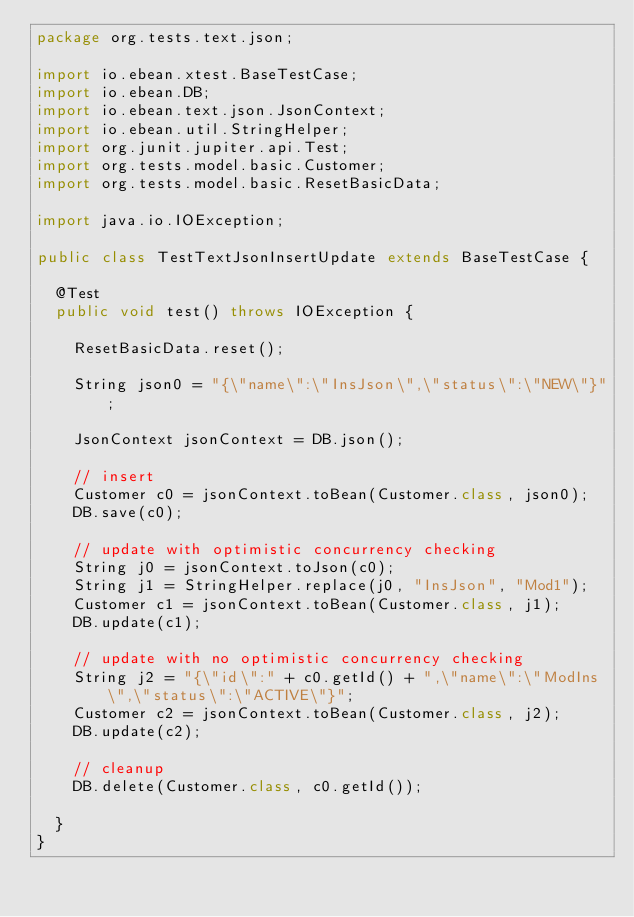<code> <loc_0><loc_0><loc_500><loc_500><_Java_>package org.tests.text.json;

import io.ebean.xtest.BaseTestCase;
import io.ebean.DB;
import io.ebean.text.json.JsonContext;
import io.ebean.util.StringHelper;
import org.junit.jupiter.api.Test;
import org.tests.model.basic.Customer;
import org.tests.model.basic.ResetBasicData;

import java.io.IOException;

public class TestTextJsonInsertUpdate extends BaseTestCase {

  @Test
  public void test() throws IOException {

    ResetBasicData.reset();

    String json0 = "{\"name\":\"InsJson\",\"status\":\"NEW\"}";

    JsonContext jsonContext = DB.json();

    // insert
    Customer c0 = jsonContext.toBean(Customer.class, json0);
    DB.save(c0);

    // update with optimistic concurrency checking
    String j0 = jsonContext.toJson(c0);
    String j1 = StringHelper.replace(j0, "InsJson", "Mod1");
    Customer c1 = jsonContext.toBean(Customer.class, j1);
    DB.update(c1);

    // update with no optimistic concurrency checking
    String j2 = "{\"id\":" + c0.getId() + ",\"name\":\"ModIns\",\"status\":\"ACTIVE\"}";
    Customer c2 = jsonContext.toBean(Customer.class, j2);
    DB.update(c2);

    // cleanup
    DB.delete(Customer.class, c0.getId());

  }
}
</code> 